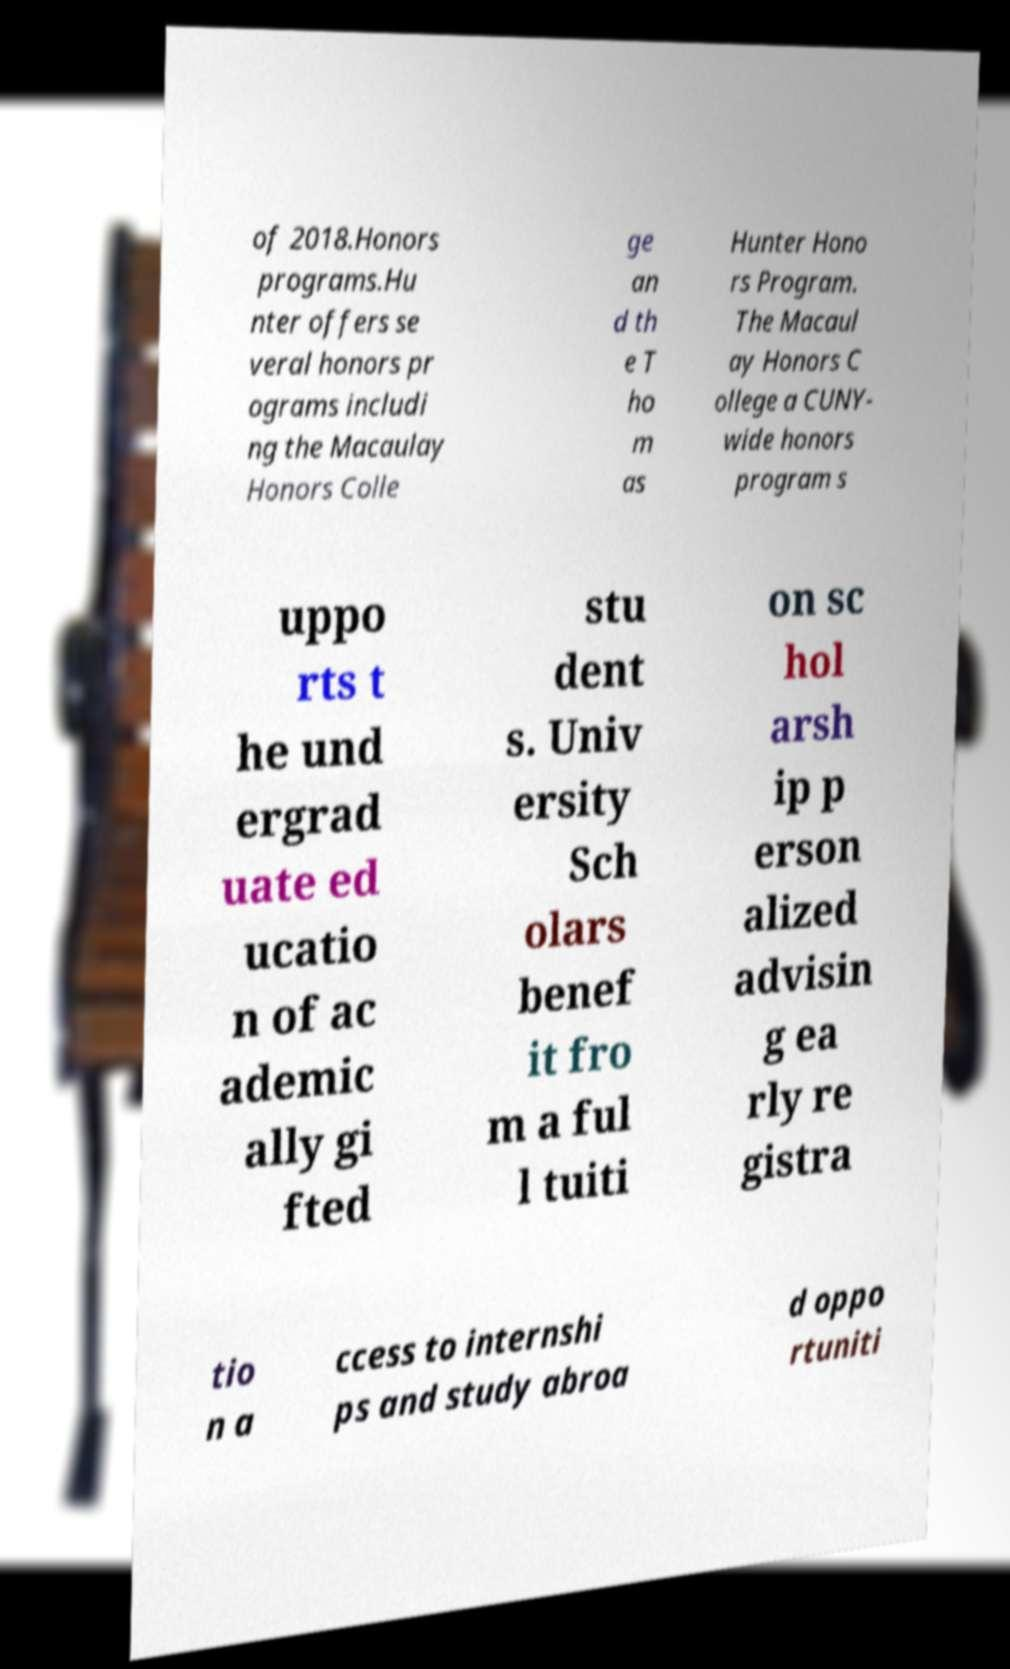Please identify and transcribe the text found in this image. of 2018.Honors programs.Hu nter offers se veral honors pr ograms includi ng the Macaulay Honors Colle ge an d th e T ho m as Hunter Hono rs Program. The Macaul ay Honors C ollege a CUNY- wide honors program s uppo rts t he und ergrad uate ed ucatio n of ac ademic ally gi fted stu dent s. Univ ersity Sch olars benef it fro m a ful l tuiti on sc hol arsh ip p erson alized advisin g ea rly re gistra tio n a ccess to internshi ps and study abroa d oppo rtuniti 